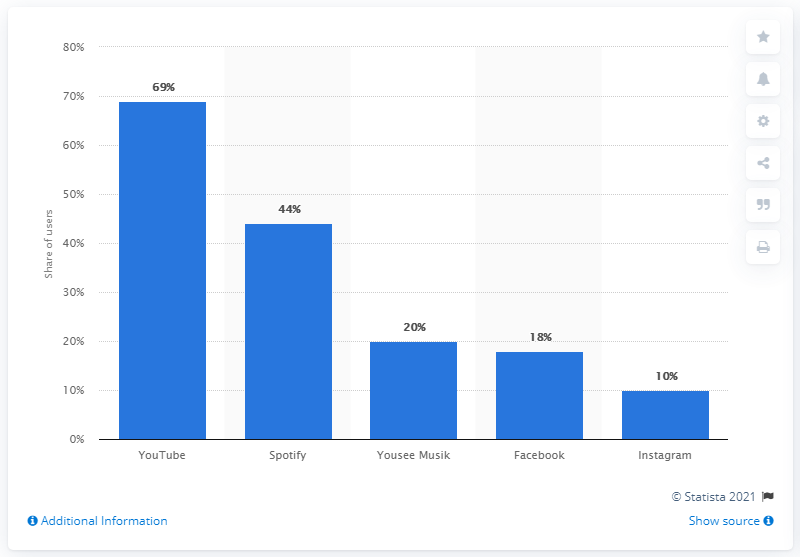What insights can we draw about music consumption habits in Denmark from this image? This bar graph highlights that video and dedicated music streaming platforms like YouTube and Spotify are the primary channels for digital music consumption in Denmark. It also suggests that social media platforms play a minor role as a source for music, with much lesser user shares for music service usage. 